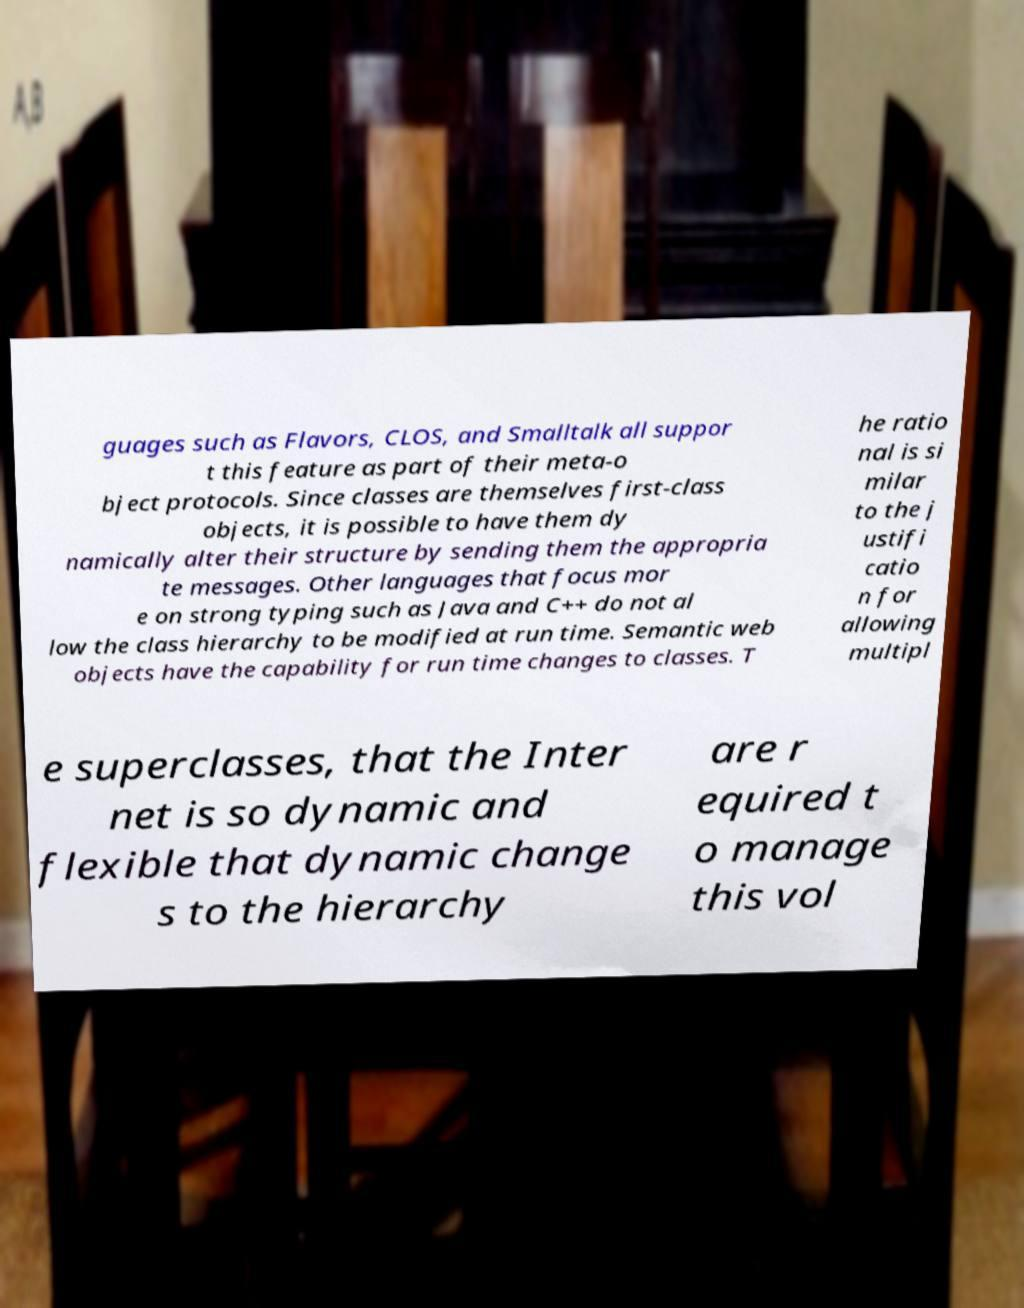For documentation purposes, I need the text within this image transcribed. Could you provide that? guages such as Flavors, CLOS, and Smalltalk all suppor t this feature as part of their meta-o bject protocols. Since classes are themselves first-class objects, it is possible to have them dy namically alter their structure by sending them the appropria te messages. Other languages that focus mor e on strong typing such as Java and C++ do not al low the class hierarchy to be modified at run time. Semantic web objects have the capability for run time changes to classes. T he ratio nal is si milar to the j ustifi catio n for allowing multipl e superclasses, that the Inter net is so dynamic and flexible that dynamic change s to the hierarchy are r equired t o manage this vol 